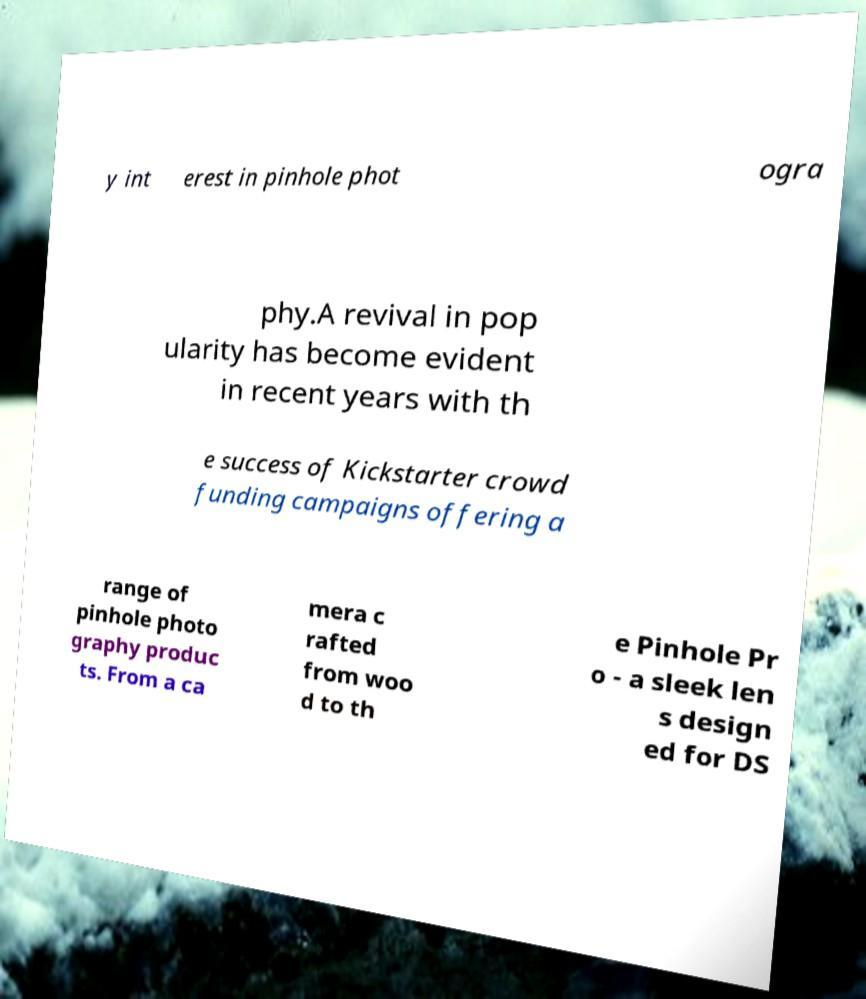Please identify and transcribe the text found in this image. y int erest in pinhole phot ogra phy.A revival in pop ularity has become evident in recent years with th e success of Kickstarter crowd funding campaigns offering a range of pinhole photo graphy produc ts. From a ca mera c rafted from woo d to th e Pinhole Pr o - a sleek len s design ed for DS 